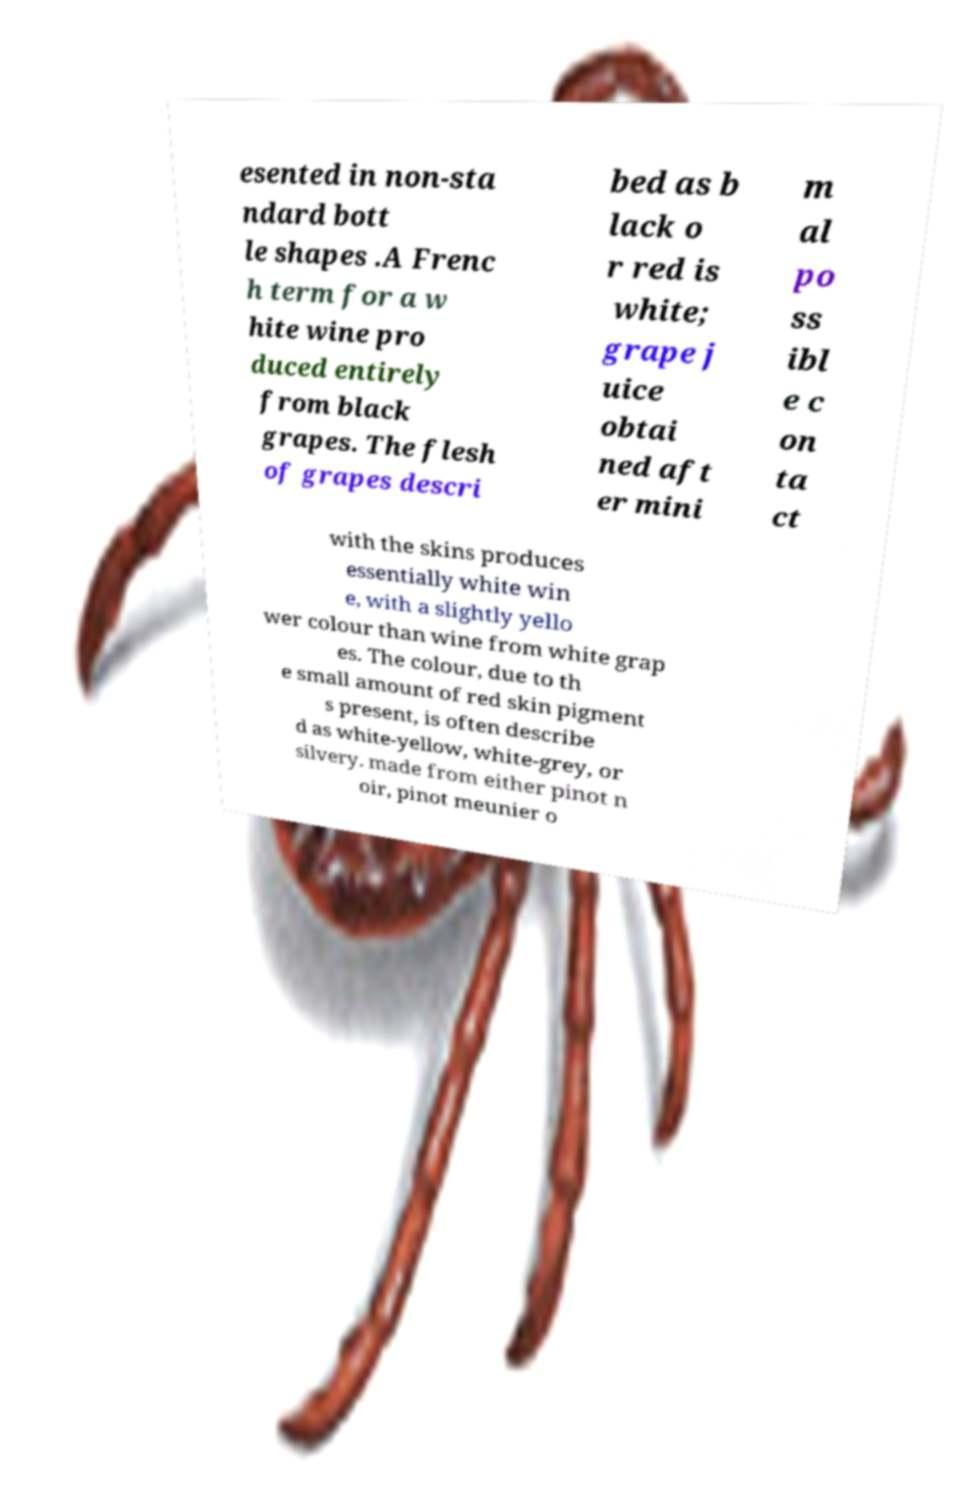Can you accurately transcribe the text from the provided image for me? esented in non-sta ndard bott le shapes .A Frenc h term for a w hite wine pro duced entirely from black grapes. The flesh of grapes descri bed as b lack o r red is white; grape j uice obtai ned aft er mini m al po ss ibl e c on ta ct with the skins produces essentially white win e, with a slightly yello wer colour than wine from white grap es. The colour, due to th e small amount of red skin pigment s present, is often describe d as white-yellow, white-grey, or silvery. made from either pinot n oir, pinot meunier o 